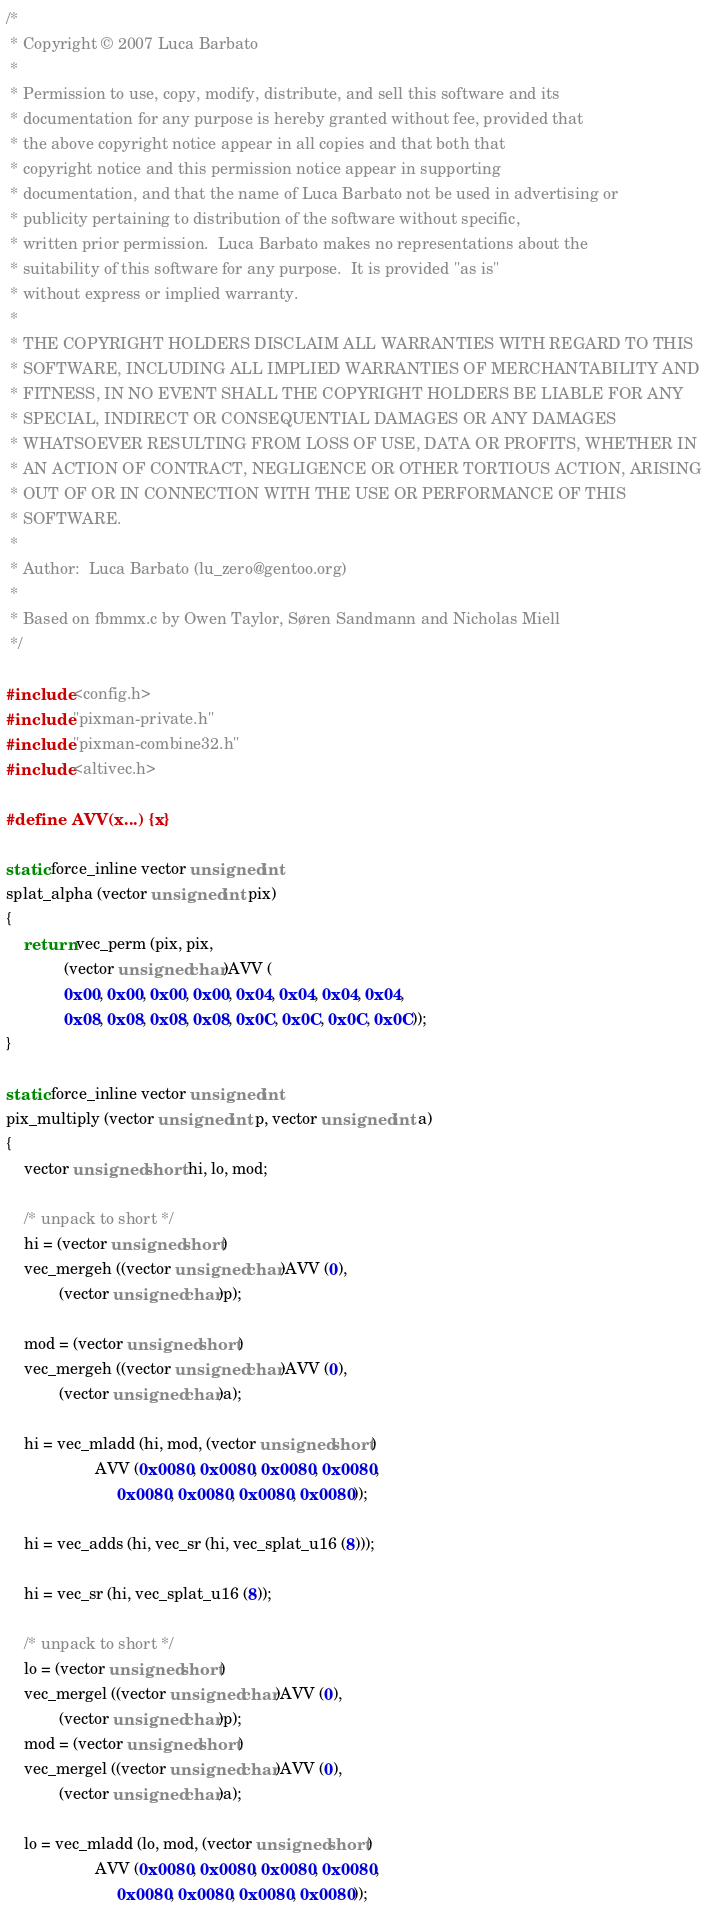Convert code to text. <code><loc_0><loc_0><loc_500><loc_500><_C_>/*
 * Copyright © 2007 Luca Barbato
 *
 * Permission to use, copy, modify, distribute, and sell this software and its
 * documentation for any purpose is hereby granted without fee, provided that
 * the above copyright notice appear in all copies and that both that
 * copyright notice and this permission notice appear in supporting
 * documentation, and that the name of Luca Barbato not be used in advertising or
 * publicity pertaining to distribution of the software without specific,
 * written prior permission.  Luca Barbato makes no representations about the
 * suitability of this software for any purpose.  It is provided "as is"
 * without express or implied warranty.
 *
 * THE COPYRIGHT HOLDERS DISCLAIM ALL WARRANTIES WITH REGARD TO THIS
 * SOFTWARE, INCLUDING ALL IMPLIED WARRANTIES OF MERCHANTABILITY AND
 * FITNESS, IN NO EVENT SHALL THE COPYRIGHT HOLDERS BE LIABLE FOR ANY
 * SPECIAL, INDIRECT OR CONSEQUENTIAL DAMAGES OR ANY DAMAGES
 * WHATSOEVER RESULTING FROM LOSS OF USE, DATA OR PROFITS, WHETHER IN
 * AN ACTION OF CONTRACT, NEGLIGENCE OR OTHER TORTIOUS ACTION, ARISING
 * OUT OF OR IN CONNECTION WITH THE USE OR PERFORMANCE OF THIS
 * SOFTWARE.
 *
 * Author:  Luca Barbato (lu_zero@gentoo.org)
 *
 * Based on fbmmx.c by Owen Taylor, Søren Sandmann and Nicholas Miell
 */

#include <config.h>
#include "pixman-private.h"
#include "pixman-combine32.h"
#include <altivec.h>

#define AVV(x...) {x}

static force_inline vector unsigned int
splat_alpha (vector unsigned int pix)
{
    return vec_perm (pix, pix,
		     (vector unsigned char)AVV (
			 0x00, 0x00, 0x00, 0x00, 0x04, 0x04, 0x04, 0x04,
			 0x08, 0x08, 0x08, 0x08, 0x0C, 0x0C, 0x0C, 0x0C));
}

static force_inline vector unsigned int
pix_multiply (vector unsigned int p, vector unsigned int a)
{
    vector unsigned short hi, lo, mod;

    /* unpack to short */
    hi = (vector unsigned short)
	vec_mergeh ((vector unsigned char)AVV (0),
		    (vector unsigned char)p);

    mod = (vector unsigned short)
	vec_mergeh ((vector unsigned char)AVV (0),
		    (vector unsigned char)a);

    hi = vec_mladd (hi, mod, (vector unsigned short)
                    AVV (0x0080, 0x0080, 0x0080, 0x0080,
                         0x0080, 0x0080, 0x0080, 0x0080));

    hi = vec_adds (hi, vec_sr (hi, vec_splat_u16 (8)));

    hi = vec_sr (hi, vec_splat_u16 (8));

    /* unpack to short */
    lo = (vector unsigned short)
	vec_mergel ((vector unsigned char)AVV (0),
		    (vector unsigned char)p);
    mod = (vector unsigned short)
	vec_mergel ((vector unsigned char)AVV (0),
		    (vector unsigned char)a);

    lo = vec_mladd (lo, mod, (vector unsigned short)
                    AVV (0x0080, 0x0080, 0x0080, 0x0080,
                         0x0080, 0x0080, 0x0080, 0x0080));
</code> 